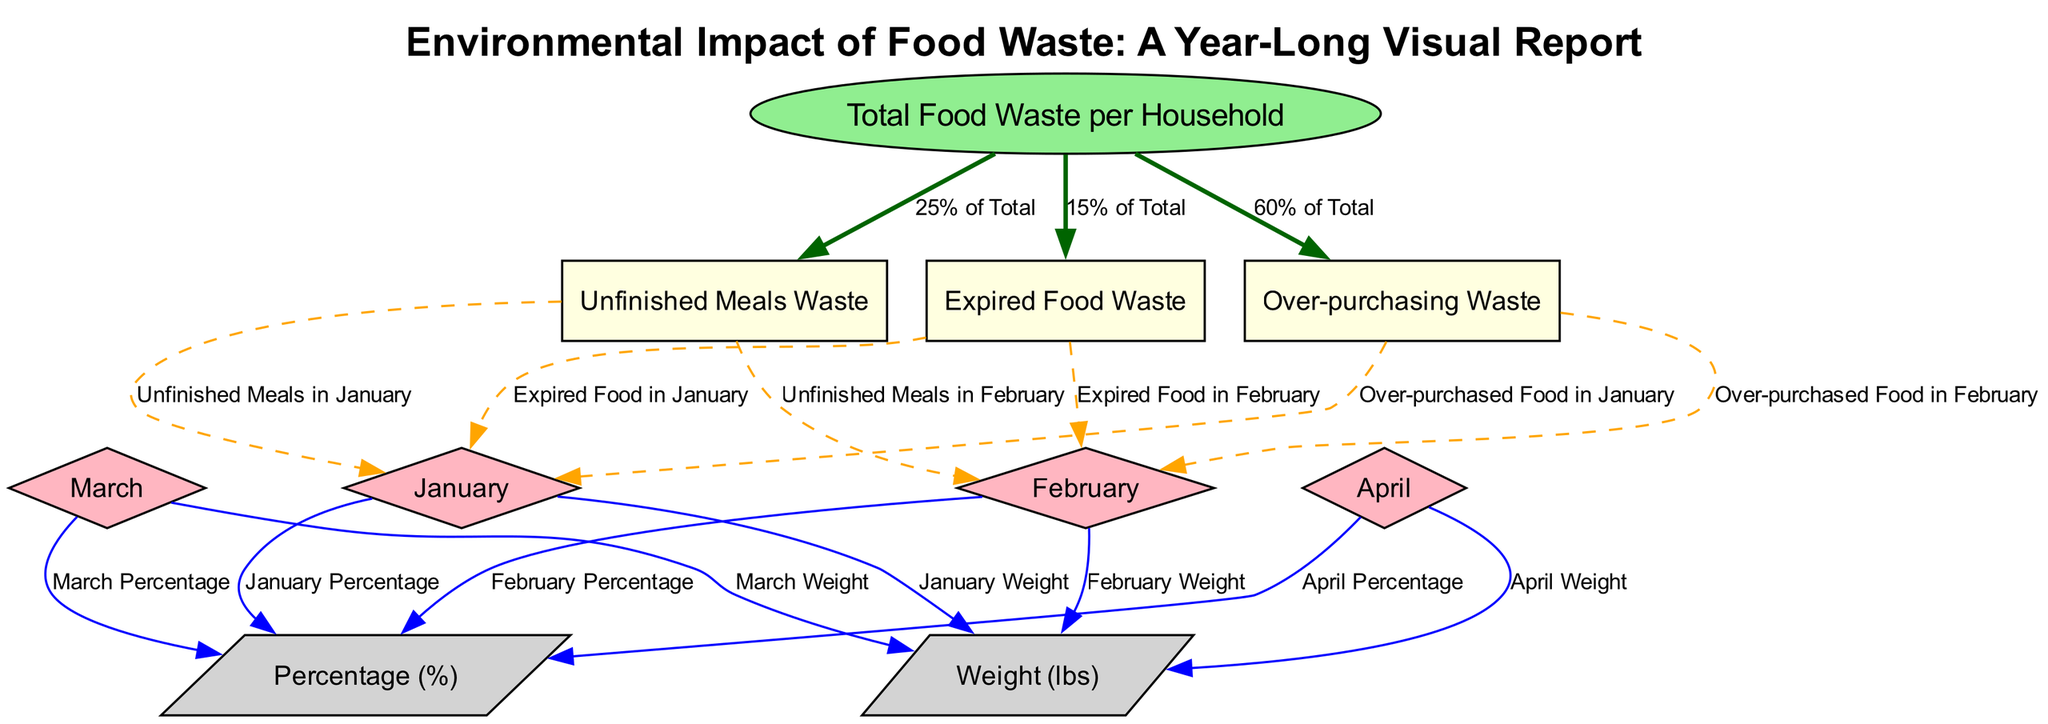What is the total percentage of expired food waste? The node for total food waste indicates that expired food waste accounts for 15% of the total waste produced by the household. Thus, direct reference from the diagram gives us the percentage.
Answer: 15% What waste category accounts for the highest percentage? By examining the connections from the total food waste node, it indicates that over-purchasing waste accounts for 60%, which is higher than the other categories of expired food (15%) and unfinished meals (25%).
Answer: Over-purchasing How many months are represented in the diagram? The diagram shows nodes representing the months of January, February, March, and April, which totals four distinct months. Thus, the count of the month nodes gives us the answer.
Answer: 4 What percentage of unfinished meals waste is reported for January? The diagram provides a direct edge from the unfinished meals waste node to the January node, which would indicate it is 25% of total waste based on the information given in the edges.
Answer: 25% What type of diagram is used here? This diagram is a Textbook Diagram, distinguished by the structured representation of relationships between food waste categories over a defined period and the visualization of data categorized in percentages and weights.
Answer: Textbook Diagram What is the weight measure for food waste in February? The February node is connected directly to a weight measure attribute through an edge, which allows us to identify the specific weight amount for food waste generated in February by reading off the edge label.
Answer: February Weight What is the total weight of food waste for the entire year represented in the diagram? The diagram mentions nodes related to each month along with a total food waste node. By adding the respective weights of food waste from each month displayed, I would sum it up. However, as the specific weight number per month is not provided in the question, it cannot be determined here.
Answer: Not provided What relationship does wasted food from over-purchasing have with the total food waste? The over-purchasing waste node is connected directly to the total food waste node in the diagram, indicating it represents 60% of the overall waste produced by the household. Thus, there's a direct relationship indicating a significant contribution to the total waste.
Answer: 60% of Total 